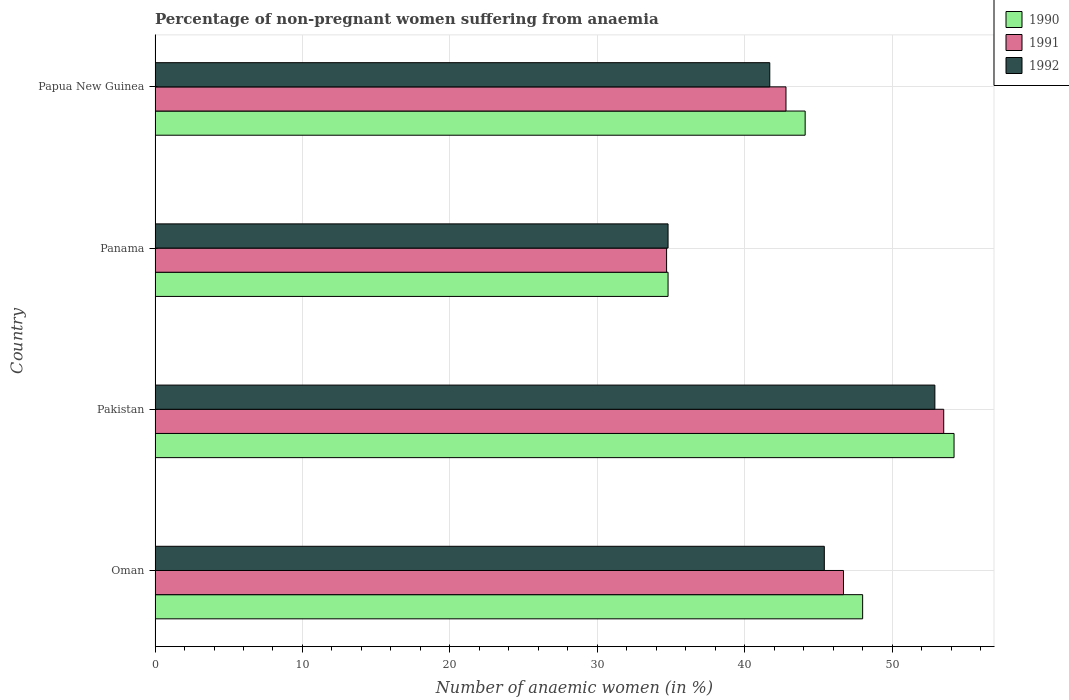How many groups of bars are there?
Your answer should be compact. 4. Are the number of bars per tick equal to the number of legend labels?
Your answer should be compact. Yes. What is the label of the 4th group of bars from the top?
Ensure brevity in your answer.  Oman. In how many cases, is the number of bars for a given country not equal to the number of legend labels?
Provide a succinct answer. 0. What is the percentage of non-pregnant women suffering from anaemia in 1990 in Pakistan?
Your answer should be compact. 54.2. Across all countries, what is the maximum percentage of non-pregnant women suffering from anaemia in 1991?
Offer a terse response. 53.5. Across all countries, what is the minimum percentage of non-pregnant women suffering from anaemia in 1990?
Your response must be concise. 34.8. In which country was the percentage of non-pregnant women suffering from anaemia in 1991 maximum?
Offer a terse response. Pakistan. In which country was the percentage of non-pregnant women suffering from anaemia in 1992 minimum?
Give a very brief answer. Panama. What is the total percentage of non-pregnant women suffering from anaemia in 1990 in the graph?
Keep it short and to the point. 181.1. What is the difference between the percentage of non-pregnant women suffering from anaemia in 1990 in Oman and that in Papua New Guinea?
Your response must be concise. 3.9. What is the difference between the percentage of non-pregnant women suffering from anaemia in 1991 in Pakistan and the percentage of non-pregnant women suffering from anaemia in 1990 in Papua New Guinea?
Your answer should be very brief. 9.4. What is the average percentage of non-pregnant women suffering from anaemia in 1992 per country?
Offer a terse response. 43.7. What is the difference between the percentage of non-pregnant women suffering from anaemia in 1992 and percentage of non-pregnant women suffering from anaemia in 1990 in Oman?
Ensure brevity in your answer.  -2.6. In how many countries, is the percentage of non-pregnant women suffering from anaemia in 1990 greater than 28 %?
Offer a terse response. 4. What is the ratio of the percentage of non-pregnant women suffering from anaemia in 1990 in Oman to that in Papua New Guinea?
Your answer should be very brief. 1.09. What is the difference between the highest and the second highest percentage of non-pregnant women suffering from anaemia in 1992?
Offer a terse response. 7.5. What is the difference between the highest and the lowest percentage of non-pregnant women suffering from anaemia in 1991?
Keep it short and to the point. 18.8. Is the sum of the percentage of non-pregnant women suffering from anaemia in 1991 in Pakistan and Panama greater than the maximum percentage of non-pregnant women suffering from anaemia in 1992 across all countries?
Keep it short and to the point. Yes. How many bars are there?
Make the answer very short. 12. Are all the bars in the graph horizontal?
Your answer should be compact. Yes. Does the graph contain any zero values?
Give a very brief answer. No. Does the graph contain grids?
Your response must be concise. Yes. Where does the legend appear in the graph?
Ensure brevity in your answer.  Top right. How many legend labels are there?
Provide a short and direct response. 3. What is the title of the graph?
Offer a very short reply. Percentage of non-pregnant women suffering from anaemia. Does "2014" appear as one of the legend labels in the graph?
Make the answer very short. No. What is the label or title of the X-axis?
Offer a terse response. Number of anaemic women (in %). What is the Number of anaemic women (in %) of 1990 in Oman?
Your response must be concise. 48. What is the Number of anaemic women (in %) of 1991 in Oman?
Your answer should be compact. 46.7. What is the Number of anaemic women (in %) in 1992 in Oman?
Give a very brief answer. 45.4. What is the Number of anaemic women (in %) in 1990 in Pakistan?
Make the answer very short. 54.2. What is the Number of anaemic women (in %) in 1991 in Pakistan?
Make the answer very short. 53.5. What is the Number of anaemic women (in %) of 1992 in Pakistan?
Offer a terse response. 52.9. What is the Number of anaemic women (in %) of 1990 in Panama?
Give a very brief answer. 34.8. What is the Number of anaemic women (in %) of 1991 in Panama?
Provide a succinct answer. 34.7. What is the Number of anaemic women (in %) in 1992 in Panama?
Ensure brevity in your answer.  34.8. What is the Number of anaemic women (in %) of 1990 in Papua New Guinea?
Provide a short and direct response. 44.1. What is the Number of anaemic women (in %) in 1991 in Papua New Guinea?
Your answer should be very brief. 42.8. What is the Number of anaemic women (in %) of 1992 in Papua New Guinea?
Ensure brevity in your answer.  41.7. Across all countries, what is the maximum Number of anaemic women (in %) of 1990?
Your answer should be compact. 54.2. Across all countries, what is the maximum Number of anaemic women (in %) of 1991?
Ensure brevity in your answer.  53.5. Across all countries, what is the maximum Number of anaemic women (in %) in 1992?
Make the answer very short. 52.9. Across all countries, what is the minimum Number of anaemic women (in %) of 1990?
Ensure brevity in your answer.  34.8. Across all countries, what is the minimum Number of anaemic women (in %) of 1991?
Your answer should be very brief. 34.7. Across all countries, what is the minimum Number of anaemic women (in %) of 1992?
Ensure brevity in your answer.  34.8. What is the total Number of anaemic women (in %) of 1990 in the graph?
Provide a succinct answer. 181.1. What is the total Number of anaemic women (in %) of 1991 in the graph?
Your answer should be compact. 177.7. What is the total Number of anaemic women (in %) in 1992 in the graph?
Provide a succinct answer. 174.8. What is the difference between the Number of anaemic women (in %) in 1991 in Oman and that in Pakistan?
Provide a succinct answer. -6.8. What is the difference between the Number of anaemic women (in %) of 1990 in Oman and that in Panama?
Give a very brief answer. 13.2. What is the difference between the Number of anaemic women (in %) in 1992 in Oman and that in Panama?
Your answer should be compact. 10.6. What is the difference between the Number of anaemic women (in %) in 1990 in Oman and that in Papua New Guinea?
Provide a short and direct response. 3.9. What is the difference between the Number of anaemic women (in %) in 1992 in Oman and that in Papua New Guinea?
Your answer should be compact. 3.7. What is the difference between the Number of anaemic women (in %) in 1990 in Pakistan and that in Panama?
Make the answer very short. 19.4. What is the difference between the Number of anaemic women (in %) of 1991 in Pakistan and that in Panama?
Provide a succinct answer. 18.8. What is the difference between the Number of anaemic women (in %) of 1992 in Pakistan and that in Panama?
Keep it short and to the point. 18.1. What is the difference between the Number of anaemic women (in %) in 1990 in Pakistan and that in Papua New Guinea?
Keep it short and to the point. 10.1. What is the difference between the Number of anaemic women (in %) of 1991 in Pakistan and that in Papua New Guinea?
Your answer should be compact. 10.7. What is the difference between the Number of anaemic women (in %) in 1992 in Pakistan and that in Papua New Guinea?
Provide a short and direct response. 11.2. What is the difference between the Number of anaemic women (in %) in 1991 in Panama and that in Papua New Guinea?
Your response must be concise. -8.1. What is the difference between the Number of anaemic women (in %) in 1992 in Panama and that in Papua New Guinea?
Give a very brief answer. -6.9. What is the difference between the Number of anaemic women (in %) of 1990 in Oman and the Number of anaemic women (in %) of 1991 in Pakistan?
Your answer should be very brief. -5.5. What is the difference between the Number of anaemic women (in %) in 1991 in Oman and the Number of anaemic women (in %) in 1992 in Pakistan?
Make the answer very short. -6.2. What is the difference between the Number of anaemic women (in %) in 1990 in Oman and the Number of anaemic women (in %) in 1991 in Panama?
Keep it short and to the point. 13.3. What is the difference between the Number of anaemic women (in %) in 1990 in Oman and the Number of anaemic women (in %) in 1992 in Panama?
Ensure brevity in your answer.  13.2. What is the difference between the Number of anaemic women (in %) of 1991 in Oman and the Number of anaemic women (in %) of 1992 in Panama?
Give a very brief answer. 11.9. What is the difference between the Number of anaemic women (in %) of 1990 in Oman and the Number of anaemic women (in %) of 1991 in Papua New Guinea?
Give a very brief answer. 5.2. What is the difference between the Number of anaemic women (in %) in 1991 in Oman and the Number of anaemic women (in %) in 1992 in Papua New Guinea?
Make the answer very short. 5. What is the difference between the Number of anaemic women (in %) in 1990 in Pakistan and the Number of anaemic women (in %) in 1992 in Panama?
Offer a very short reply. 19.4. What is the difference between the Number of anaemic women (in %) of 1990 in Pakistan and the Number of anaemic women (in %) of 1992 in Papua New Guinea?
Your answer should be compact. 12.5. What is the difference between the Number of anaemic women (in %) in 1991 in Pakistan and the Number of anaemic women (in %) in 1992 in Papua New Guinea?
Your response must be concise. 11.8. What is the difference between the Number of anaemic women (in %) in 1990 in Panama and the Number of anaemic women (in %) in 1992 in Papua New Guinea?
Offer a terse response. -6.9. What is the difference between the Number of anaemic women (in %) in 1991 in Panama and the Number of anaemic women (in %) in 1992 in Papua New Guinea?
Your response must be concise. -7. What is the average Number of anaemic women (in %) of 1990 per country?
Your answer should be compact. 45.27. What is the average Number of anaemic women (in %) in 1991 per country?
Offer a terse response. 44.42. What is the average Number of anaemic women (in %) in 1992 per country?
Your response must be concise. 43.7. What is the difference between the Number of anaemic women (in %) of 1990 and Number of anaemic women (in %) of 1992 in Oman?
Provide a succinct answer. 2.6. What is the difference between the Number of anaemic women (in %) in 1991 and Number of anaemic women (in %) in 1992 in Pakistan?
Offer a very short reply. 0.6. What is the difference between the Number of anaemic women (in %) of 1990 and Number of anaemic women (in %) of 1991 in Panama?
Provide a short and direct response. 0.1. What is the difference between the Number of anaemic women (in %) in 1991 and Number of anaemic women (in %) in 1992 in Panama?
Offer a very short reply. -0.1. What is the difference between the Number of anaemic women (in %) of 1990 and Number of anaemic women (in %) of 1991 in Papua New Guinea?
Your answer should be compact. 1.3. What is the difference between the Number of anaemic women (in %) of 1991 and Number of anaemic women (in %) of 1992 in Papua New Guinea?
Ensure brevity in your answer.  1.1. What is the ratio of the Number of anaemic women (in %) in 1990 in Oman to that in Pakistan?
Your answer should be very brief. 0.89. What is the ratio of the Number of anaemic women (in %) of 1991 in Oman to that in Pakistan?
Ensure brevity in your answer.  0.87. What is the ratio of the Number of anaemic women (in %) in 1992 in Oman to that in Pakistan?
Provide a short and direct response. 0.86. What is the ratio of the Number of anaemic women (in %) of 1990 in Oman to that in Panama?
Your answer should be compact. 1.38. What is the ratio of the Number of anaemic women (in %) of 1991 in Oman to that in Panama?
Provide a succinct answer. 1.35. What is the ratio of the Number of anaemic women (in %) of 1992 in Oman to that in Panama?
Your answer should be compact. 1.3. What is the ratio of the Number of anaemic women (in %) of 1990 in Oman to that in Papua New Guinea?
Provide a succinct answer. 1.09. What is the ratio of the Number of anaemic women (in %) of 1991 in Oman to that in Papua New Guinea?
Ensure brevity in your answer.  1.09. What is the ratio of the Number of anaemic women (in %) of 1992 in Oman to that in Papua New Guinea?
Provide a succinct answer. 1.09. What is the ratio of the Number of anaemic women (in %) in 1990 in Pakistan to that in Panama?
Give a very brief answer. 1.56. What is the ratio of the Number of anaemic women (in %) of 1991 in Pakistan to that in Panama?
Make the answer very short. 1.54. What is the ratio of the Number of anaemic women (in %) of 1992 in Pakistan to that in Panama?
Your answer should be very brief. 1.52. What is the ratio of the Number of anaemic women (in %) of 1990 in Pakistan to that in Papua New Guinea?
Your answer should be very brief. 1.23. What is the ratio of the Number of anaemic women (in %) in 1992 in Pakistan to that in Papua New Guinea?
Your answer should be very brief. 1.27. What is the ratio of the Number of anaemic women (in %) in 1990 in Panama to that in Papua New Guinea?
Your answer should be compact. 0.79. What is the ratio of the Number of anaemic women (in %) of 1991 in Panama to that in Papua New Guinea?
Ensure brevity in your answer.  0.81. What is the ratio of the Number of anaemic women (in %) of 1992 in Panama to that in Papua New Guinea?
Provide a short and direct response. 0.83. What is the difference between the highest and the second highest Number of anaemic women (in %) in 1991?
Provide a succinct answer. 6.8. What is the difference between the highest and the second highest Number of anaemic women (in %) in 1992?
Your answer should be compact. 7.5. What is the difference between the highest and the lowest Number of anaemic women (in %) in 1990?
Ensure brevity in your answer.  19.4. 